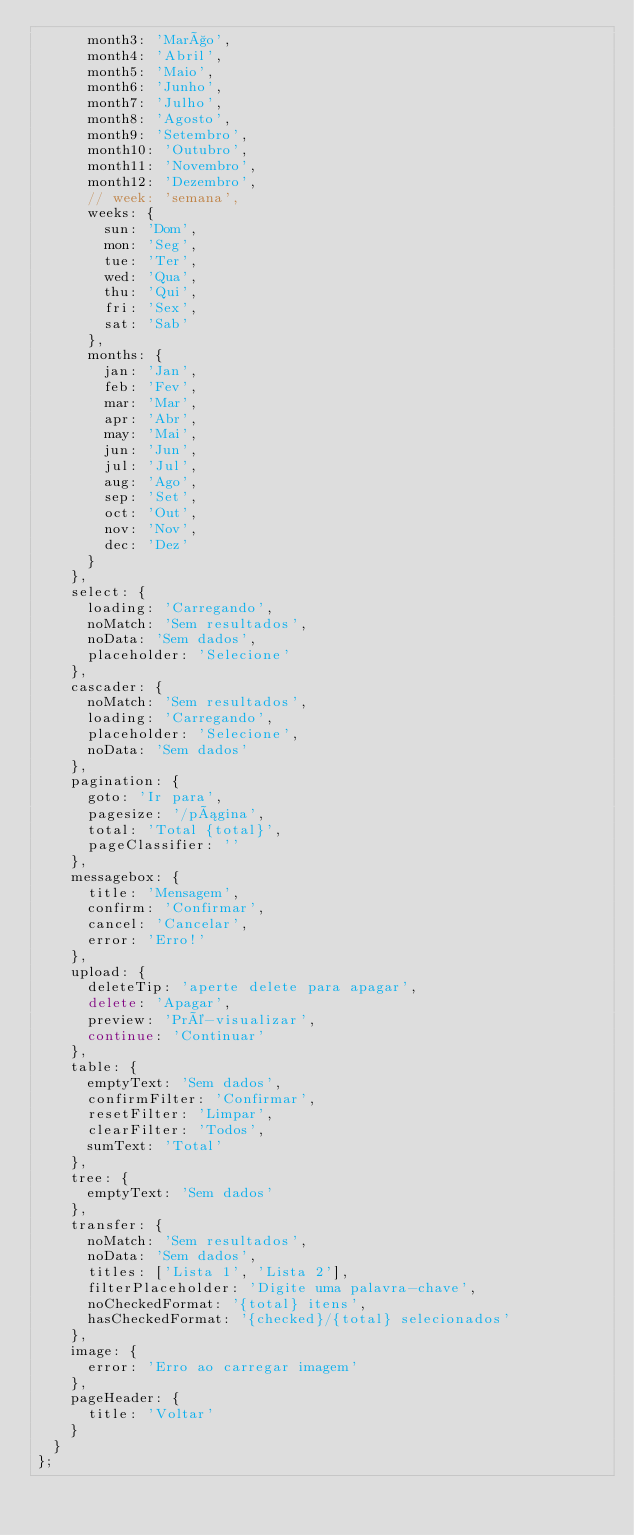<code> <loc_0><loc_0><loc_500><loc_500><_JavaScript_>      month3: 'Março',
      month4: 'Abril',
      month5: 'Maio',
      month6: 'Junho',
      month7: 'Julho',
      month8: 'Agosto',
      month9: 'Setembro',
      month10: 'Outubro',
      month11: 'Novembro',
      month12: 'Dezembro',
      // week: 'semana',
      weeks: {
        sun: 'Dom',
        mon: 'Seg',
        tue: 'Ter',
        wed: 'Qua',
        thu: 'Qui',
        fri: 'Sex',
        sat: 'Sab'
      },
      months: {
        jan: 'Jan',
        feb: 'Fev',
        mar: 'Mar',
        apr: 'Abr',
        may: 'Mai',
        jun: 'Jun',
        jul: 'Jul',
        aug: 'Ago',
        sep: 'Set',
        oct: 'Out',
        nov: 'Nov',
        dec: 'Dez'
      }
    },
    select: {
      loading: 'Carregando',
      noMatch: 'Sem resultados',
      noData: 'Sem dados',
      placeholder: 'Selecione'
    },
    cascader: {
      noMatch: 'Sem resultados',
      loading: 'Carregando',
      placeholder: 'Selecione',
      noData: 'Sem dados'
    },
    pagination: {
      goto: 'Ir para',
      pagesize: '/página',
      total: 'Total {total}',
      pageClassifier: ''
    },
    messagebox: {
      title: 'Mensagem',
      confirm: 'Confirmar',
      cancel: 'Cancelar',
      error: 'Erro!'
    },
    upload: {
      deleteTip: 'aperte delete para apagar',
      delete: 'Apagar',
      preview: 'Pré-visualizar',
      continue: 'Continuar'
    },
    table: {
      emptyText: 'Sem dados',
      confirmFilter: 'Confirmar',
      resetFilter: 'Limpar',
      clearFilter: 'Todos',
      sumText: 'Total'
    },
    tree: {
      emptyText: 'Sem dados'
    },
    transfer: {
      noMatch: 'Sem resultados',
      noData: 'Sem dados',
      titles: ['Lista 1', 'Lista 2'],
      filterPlaceholder: 'Digite uma palavra-chave',
      noCheckedFormat: '{total} itens',
      hasCheckedFormat: '{checked}/{total} selecionados'
    },
    image: {
      error: 'Erro ao carregar imagem'
    },
    pageHeader: {
      title: 'Voltar'
    }
  }
};
</code> 